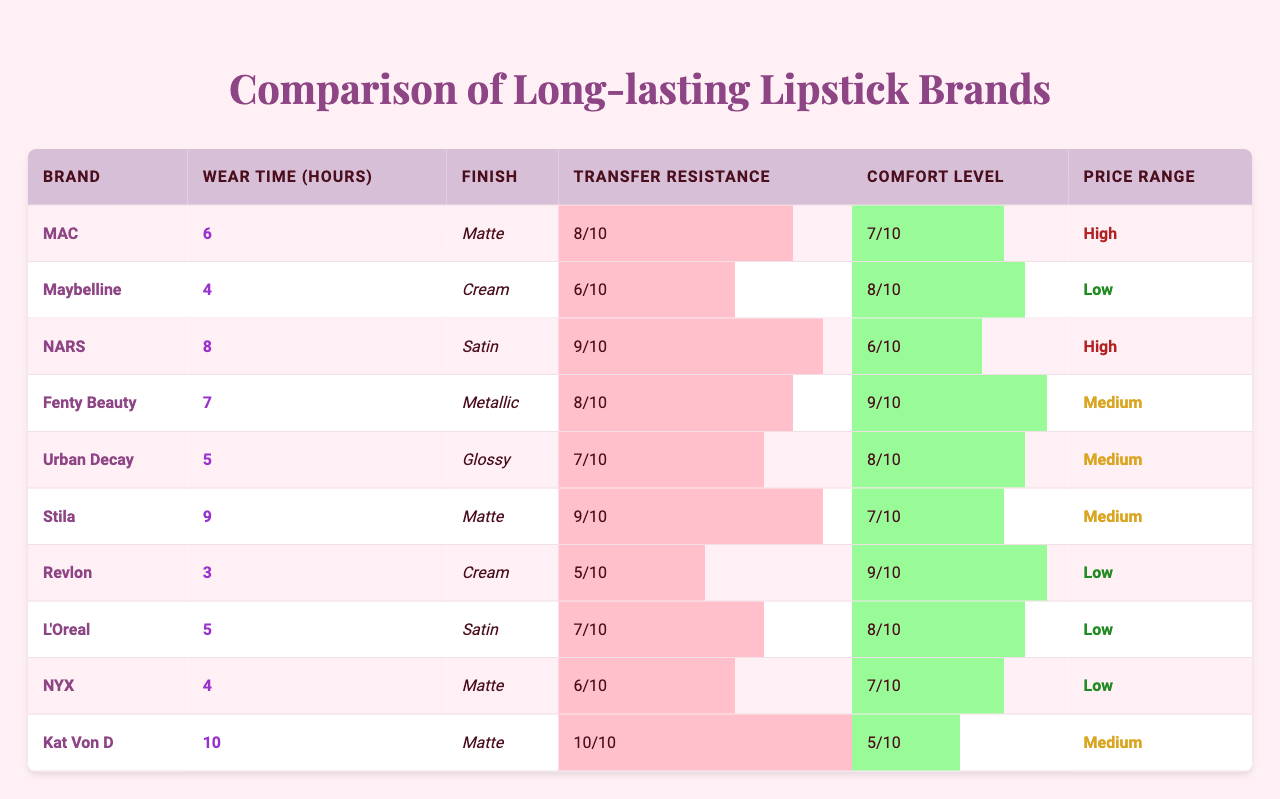What is the wear time of Stila lipstick? From the table, under the "Wear Time (hours)" column, we see Stila listed with a wear time of 9 hours.
Answer: 9 Which lipstick brand has the longest wear time? By checking the "Wear Time (hours)" column, we find Kat Von D with the highest value of 10 hours.
Answer: Kat Von D How many brands have a wear time of 5 or more hours? Looking at the "Wear Time (hours)" column, we find the following brands with wear times of 5 hours or more: MAC (6), NARS (8), Fenty Beauty (7), Stila (9), and Kat Von D (10), totaling 5 brands.
Answer: 5 What is the average transfer resistance score of all the brands? We add all the transfer resistance scores: 8 + 6 + 9 + 8 + 7 + 9 + 5 + 7 + 6 + 10 = 75. Then, dividing by the number of brands (10), we find the average to be 75/10 = 7.5.
Answer: 7.5 Is there any brand that offers a high price range with a wear time of 6 hours or more? Checking the "Price Range" and "Wear Time (hours)" columns, MAC and NARS are both high-priced and have wear times of 6 (MAC) and 8 (NARS) hours respectively.
Answer: Yes What brand has the best balance between comfort level and transfer resistance? Analyzing both the "Comfort Level" and "Transfer Resistance" scores, Stila has a comfort score of 7 and a transfer resistance score of 9, showing a good balance.
Answer: Stila Which brand has the lowest wear time, and how much is it? In the "Wear Time (hours)" column, Revlon is listed with the lowest wear time of 3 hours.
Answer: Revlon, 3 hours How does the average wear time of medium-priced brands compare to that of high-priced brands? The medium-priced brands are Fenty Beauty (7), Stila (9), and L'Oreal (5), giving an average of (7 + 9 + 5) / 3 = 21/3 = 7 hours. The high-priced brands are MAC (6) and NARS (8), with an average of (6 + 8) / 2 = 14/2 = 7 hours. Both averages are equal at 7 hours.
Answer: They are equal at 7 hours Do any brands have the same wear time? After examining the "Wear Time (hours)", we see that MAC (6) and L'Oreal (5) have the same wear time, indicating a duplicate value.
Answer: Yes, brands have the same wear time Which brand is the most comfortable, and what is its score? Looking at the "Comfort Level" column, Fenty Beauty has the highest score at 9, making it the most comfortable brand listed.
Answer: Fenty Beauty, 9 